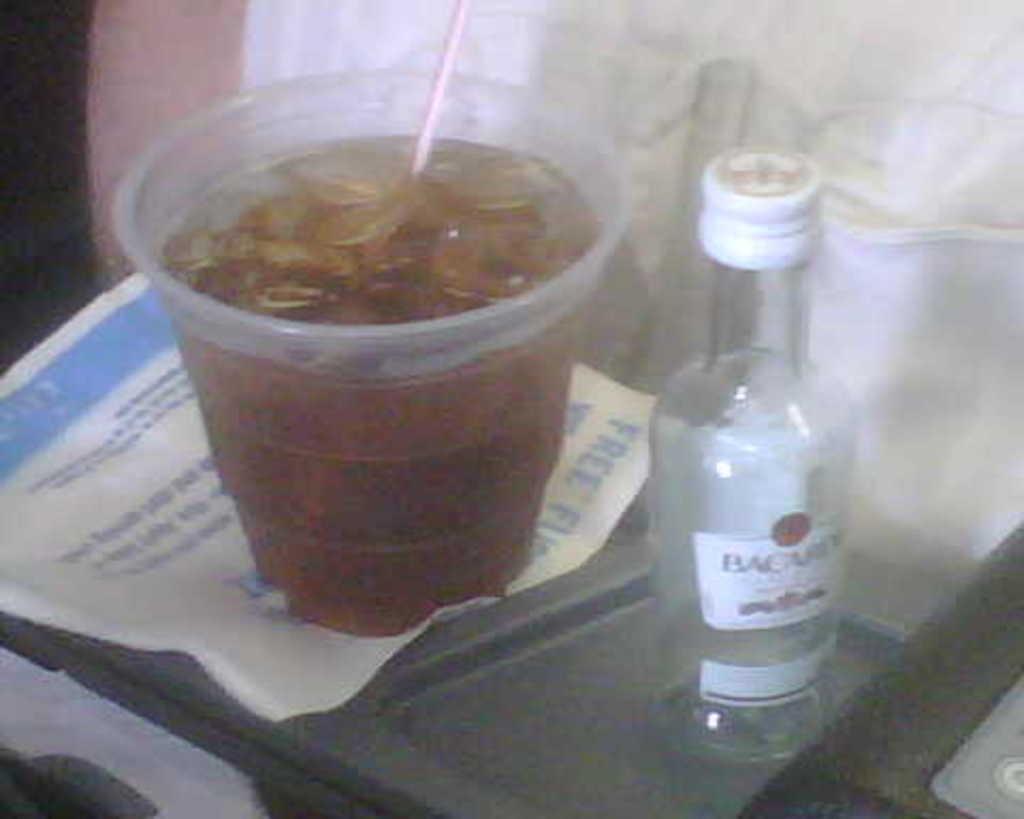What brand of alcohol is this?
Give a very brief answer. Bacardi. Does the napkin say "free" on it?
Give a very brief answer. Yes. 